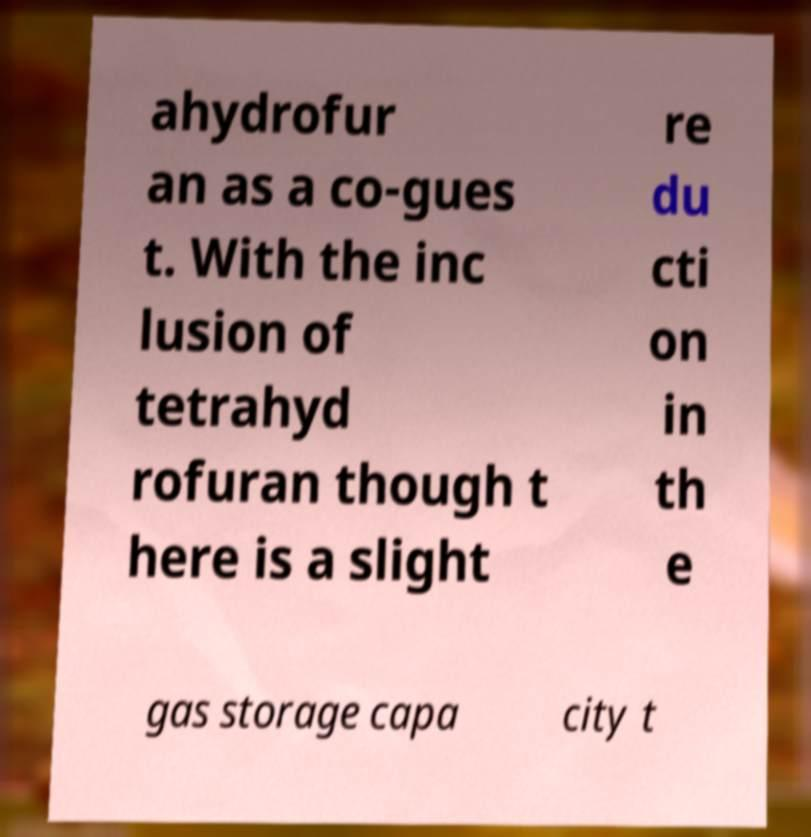Can you read and provide the text displayed in the image?This photo seems to have some interesting text. Can you extract and type it out for me? ahydrofur an as a co-gues t. With the inc lusion of tetrahyd rofuran though t here is a slight re du cti on in th e gas storage capa city t 